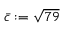<formula> <loc_0><loc_0><loc_500><loc_500>\bar { c } \colon = \sqrt { 7 9 }</formula> 